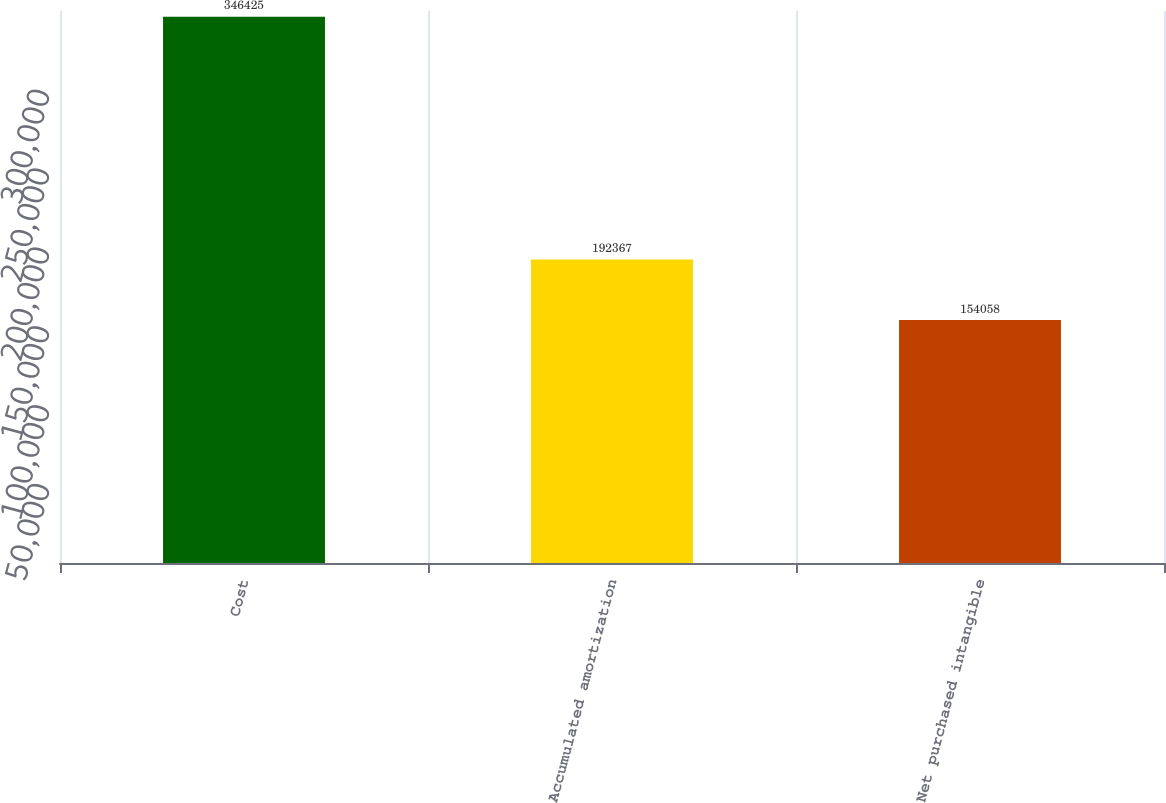Convert chart. <chart><loc_0><loc_0><loc_500><loc_500><bar_chart><fcel>Cost<fcel>Accumulated amortization<fcel>Net purchased intangible<nl><fcel>346425<fcel>192367<fcel>154058<nl></chart> 